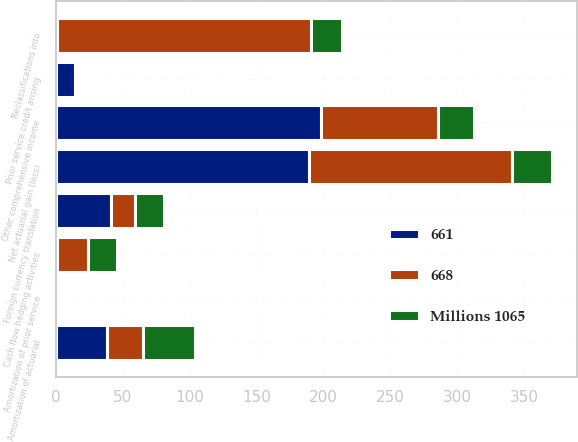Convert chart to OTSL. <chart><loc_0><loc_0><loc_500><loc_500><stacked_bar_chart><ecel><fcel>Cash flow hedging activities<fcel>Reclassifications into<fcel>Foreign currency translation<fcel>Prior service credit arising<fcel>Amortization of prior service<fcel>Net actuarial gain (loss)<fcel>Amortization of actuarial<fcel>Other comprehensive income<nl><fcel>661<fcel>1<fcel>1<fcel>41<fcel>14<fcel>2<fcel>189<fcel>38<fcel>198<nl><fcel>Millions 1065<fcel>22<fcel>23<fcel>22<fcel>1<fcel>1<fcel>30<fcel>39<fcel>27<nl><fcel>668<fcel>23<fcel>190<fcel>18<fcel>1<fcel>2<fcel>152<fcel>27<fcel>88<nl></chart> 